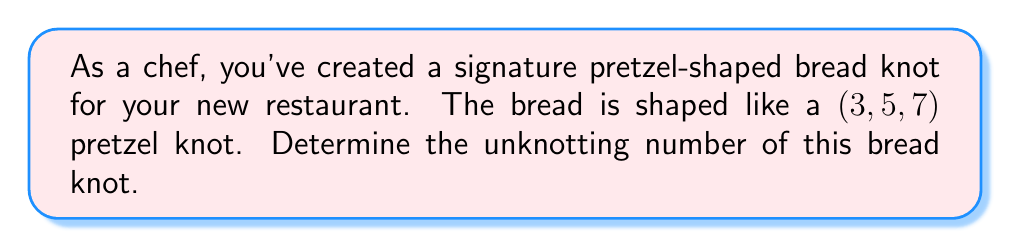Could you help me with this problem? To determine the unknotting number of the $(3,5,7)$ pretzel knot, we'll follow these steps:

1) The $(p,q,r)$ pretzel knot, where $p$, $q$, and $r$ are odd integers, has an unknotting number given by the formula:

   $$u(K) = \frac{|p| + |q| + |r| - 1}{2}$$

2) In this case, we have $p=3$, $q=5$, and $r=7$. Let's substitute these values:

   $$u(K) = \frac{|3| + |5| + |7| - 1}{2}$$

3) Simplify the absolute values:

   $$u(K) = \frac{3 + 5 + 7 - 1}{2}$$

4) Add the numbers in the numerator:

   $$u(K) = \frac{15 - 1}{2} = \frac{14}{2}$$

5) Perform the division:

   $$u(K) = 7$$

Therefore, the unknotting number of the $(3,5,7)$ pretzel knot bread is 7, meaning it would take a minimum of 7 crossing changes to transform this knot into an unknot (a simple loop).
Answer: $7$ 